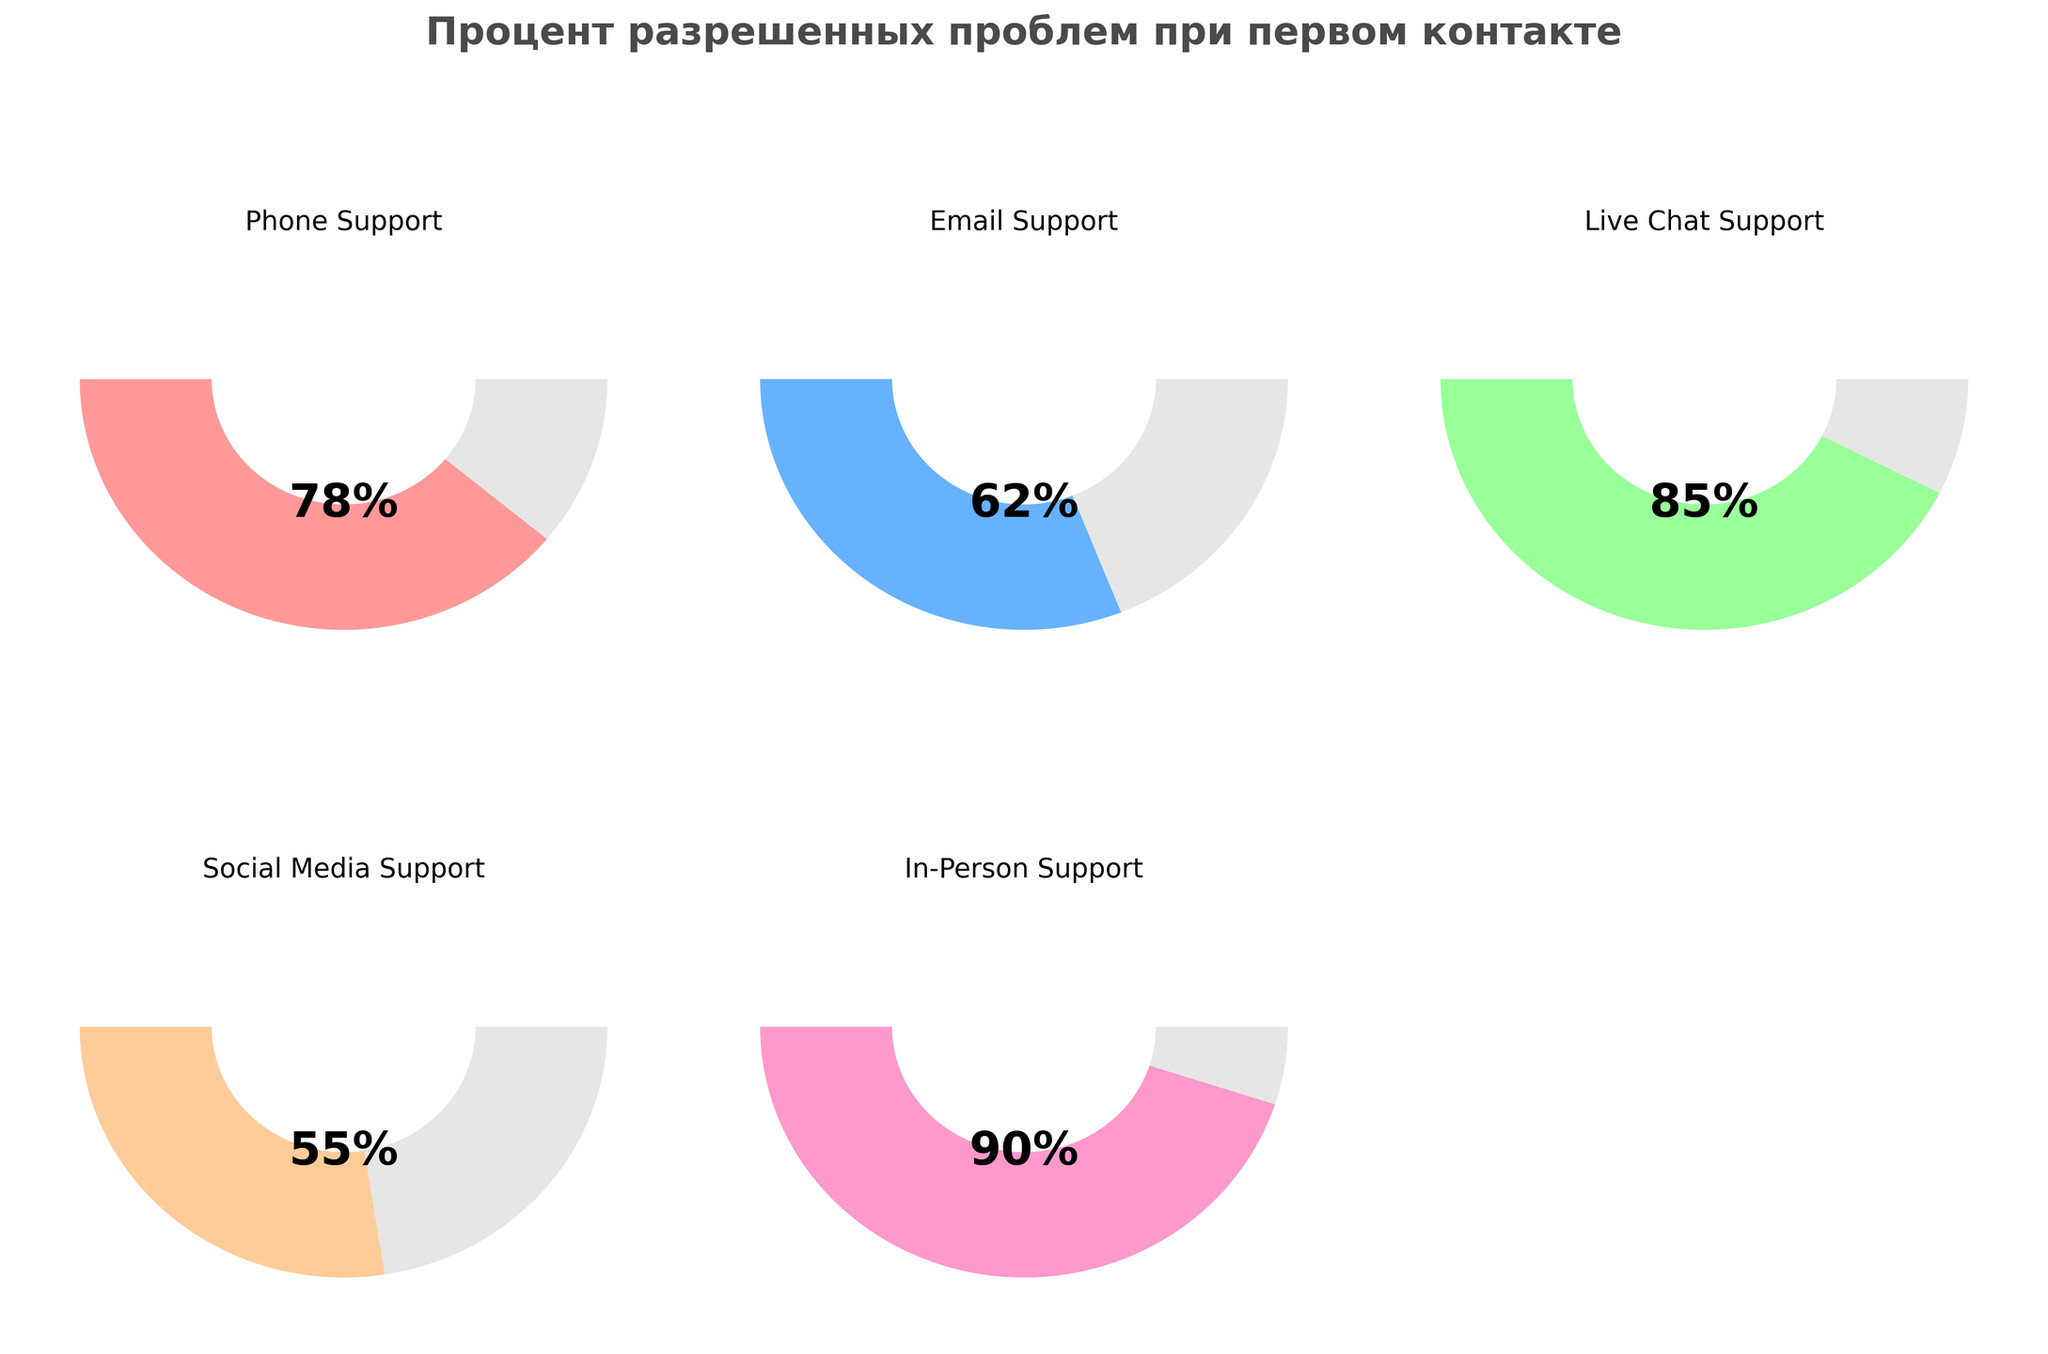What's the title of the figure? The title is "Процент разрешенных проблем при первом контакте", which means "Percentage of resolved issues on first contact". The title is prominently displayed at the top of the figure in bold letters.
Answer: Процент разрешенных проблем при первом контакте How many support channels are displayed in the figure? Each subplot represents a different tech support channel and there are 5 subplots corresponding to Phone Support, Email Support, Live Chat Support, Social Media Support, and In-Person Support.
Answer: 5 Which support channel has the highest percentage of resolved issues on first contact? To find this, compare the percentages for each channel. The In-Person Support channel has the highest percentage at 90%.
Answer: In-Person Support Which support channel has the lowest percentage of resolved issues on first contact? Check each subplot to compare percentages. The Social Media Support channel has the lowest percentage at 55%.
Answer: Social Media Support What is the percentage of resolved issues on first contact for Email Support? Look at the subplot labeled "Email Support"; the percentage displayed is 62%.
Answer: 62% What is the average percentage of resolved issues on first contact for all tech support channels? To find the average, add up all the percentages and then divide by the number of channels. The percentages are 78, 62, 85, 55, and 90. Their sum is 370. Divide 370 by 5 to get the average: 370/5 = 74.
Answer: 74 What is the difference in the percentage of resolved issues between Live Chat Support and Social Media Support? Subtract the percentage of Social Media Support (55%) from that of Live Chat Support (85%): 85 - 55 = 30.
Answer: 30 Which two support channels have the closest percentages of resolved issues on first contact? Compare the percentages: Phone Support (78%), Email Support (62%), Live Chat Support (85%), Social Media Support (55%), and In-Person Support (90%). Phone Support (78%) and Live Chat Support (85%) are the closest, with a difference of 7%.
Answer: Phone Support and Live Chat Support In terms of visual appearance, what is common among all gauge charts in the figure? Each gauge chart has a semi-circular arc representing the percentage, a text label of the percentage, and the name of the support channel. All gauges also have a gray segment to represent the unachieved percentage up to 180 degrees.
Answer: Semi-circular arc, percentage text, channel name, gray segment 